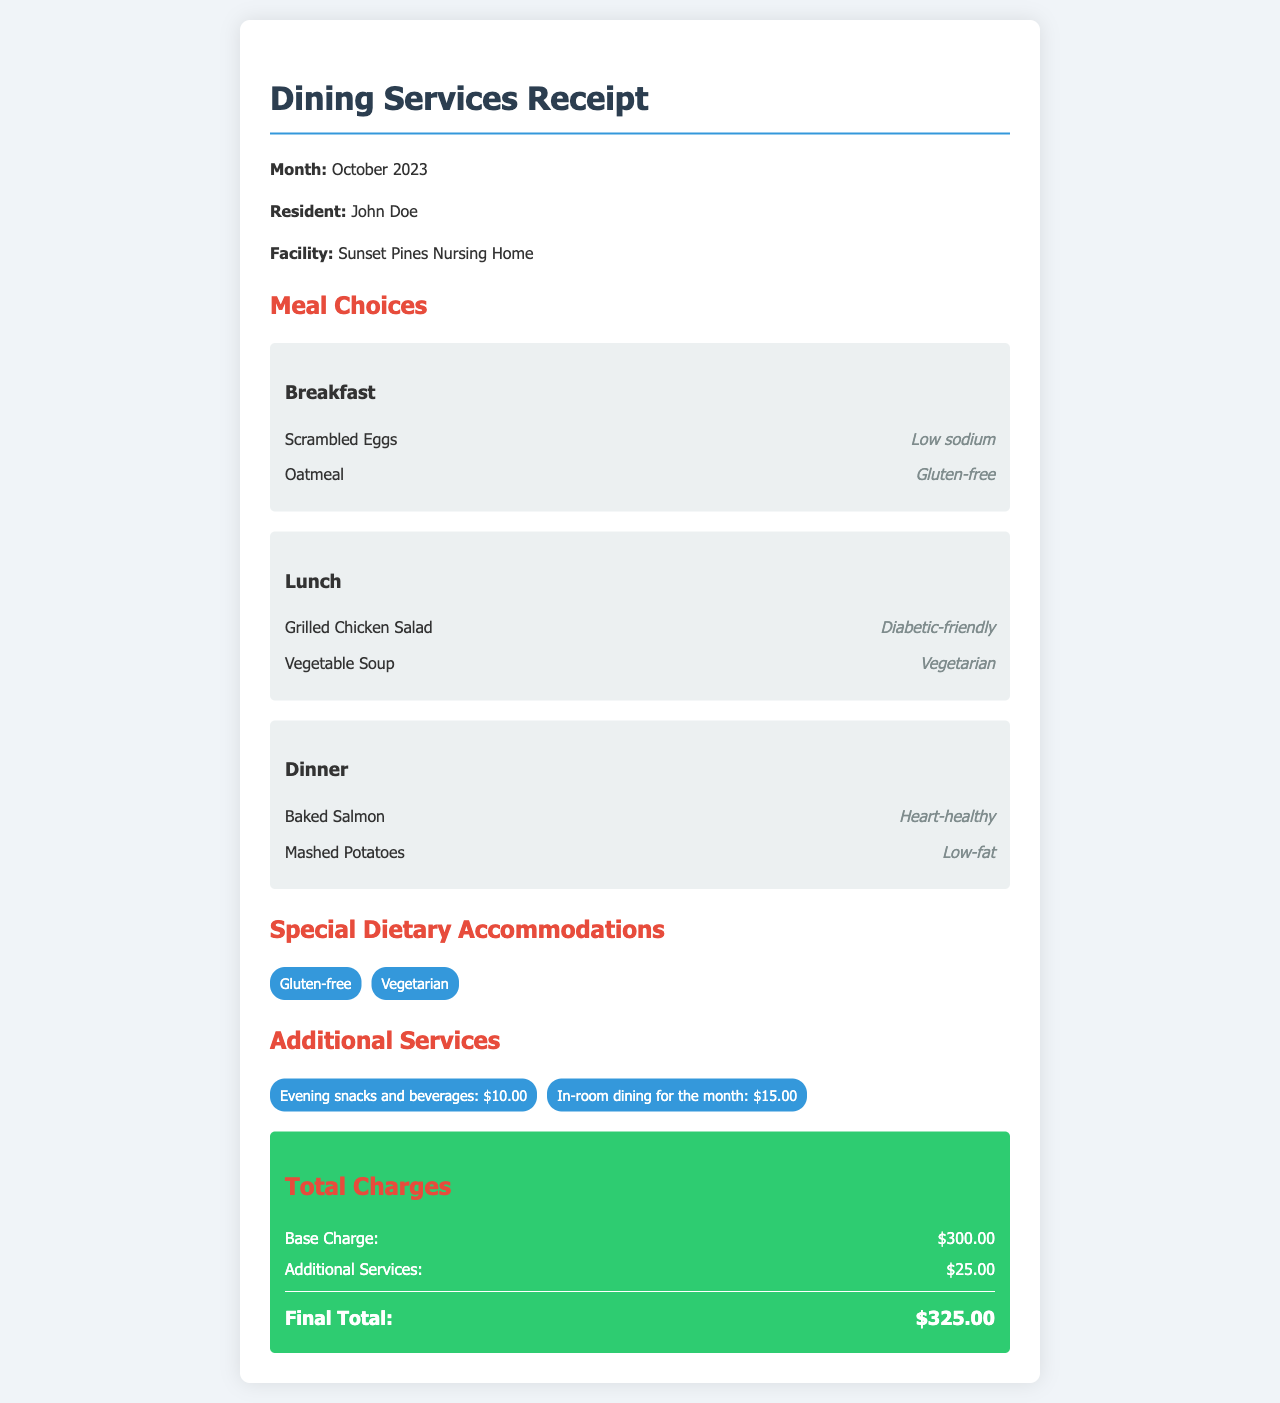What is the name of the resident? The resident's name is mentioned at the top of the receipt.
Answer: John Doe What is the total charge for additional services? The receipt lists additional services and their charges totaling to a specific amount.
Answer: $25.00 Which meal option is diabetic-friendly? The lunch section lists various meals, specifying which is diabetic-friendly.
Answer: Grilled Chicken Salad How much is charged for in-room dining for the month? The receipt includes a line item for in-room dining with a specific charge.
Answer: $15.00 What special dietary accommodation is listed for breakfast? In the breakfast section, one of the meals has a specific dietary accommodation noted.
Answer: Gluten-free What is the base charge for dining services? The document provides a clear amount for the base charge at the bottom.
Answer: $300.00 How many meal sections are listed in the receipt? The receipt has clearly defined sections for each meal type.
Answer: 3 What is the final total amount due for the month? The bottom of the receipt summarizes the total charges to indicate the final amount due.
Answer: $325.00 Which meal option is stated to be heart-healthy? The dinner section lists a meal with a specific designation noted in the description.
Answer: Baked Salmon 